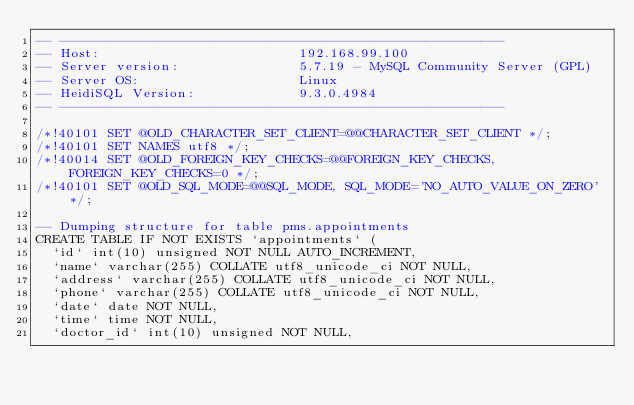Convert code to text. <code><loc_0><loc_0><loc_500><loc_500><_SQL_>-- --------------------------------------------------------
-- Host:                         192.168.99.100
-- Server version:               5.7.19 - MySQL Community Server (GPL)
-- Server OS:                    Linux
-- HeidiSQL Version:             9.3.0.4984
-- --------------------------------------------------------

/*!40101 SET @OLD_CHARACTER_SET_CLIENT=@@CHARACTER_SET_CLIENT */;
/*!40101 SET NAMES utf8 */;
/*!40014 SET @OLD_FOREIGN_KEY_CHECKS=@@FOREIGN_KEY_CHECKS, FOREIGN_KEY_CHECKS=0 */;
/*!40101 SET @OLD_SQL_MODE=@@SQL_MODE, SQL_MODE='NO_AUTO_VALUE_ON_ZERO' */;

-- Dumping structure for table pms.appointments
CREATE TABLE IF NOT EXISTS `appointments` (
  `id` int(10) unsigned NOT NULL AUTO_INCREMENT,
  `name` varchar(255) COLLATE utf8_unicode_ci NOT NULL,
  `address` varchar(255) COLLATE utf8_unicode_ci NOT NULL,
  `phone` varchar(255) COLLATE utf8_unicode_ci NOT NULL,
  `date` date NOT NULL,
  `time` time NOT NULL,
  `doctor_id` int(10) unsigned NOT NULL,</code> 